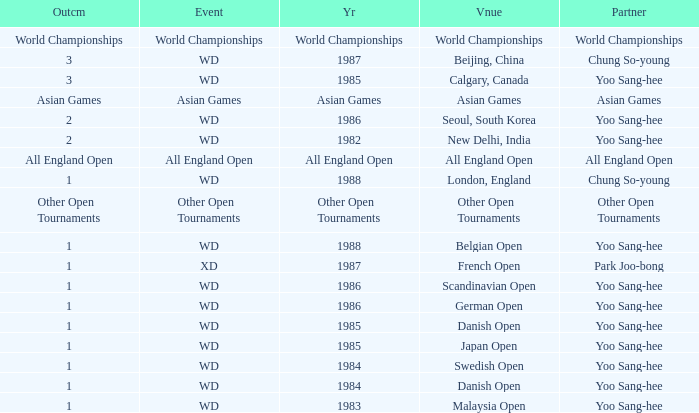What is the ally during the asian games year? Asian Games. 